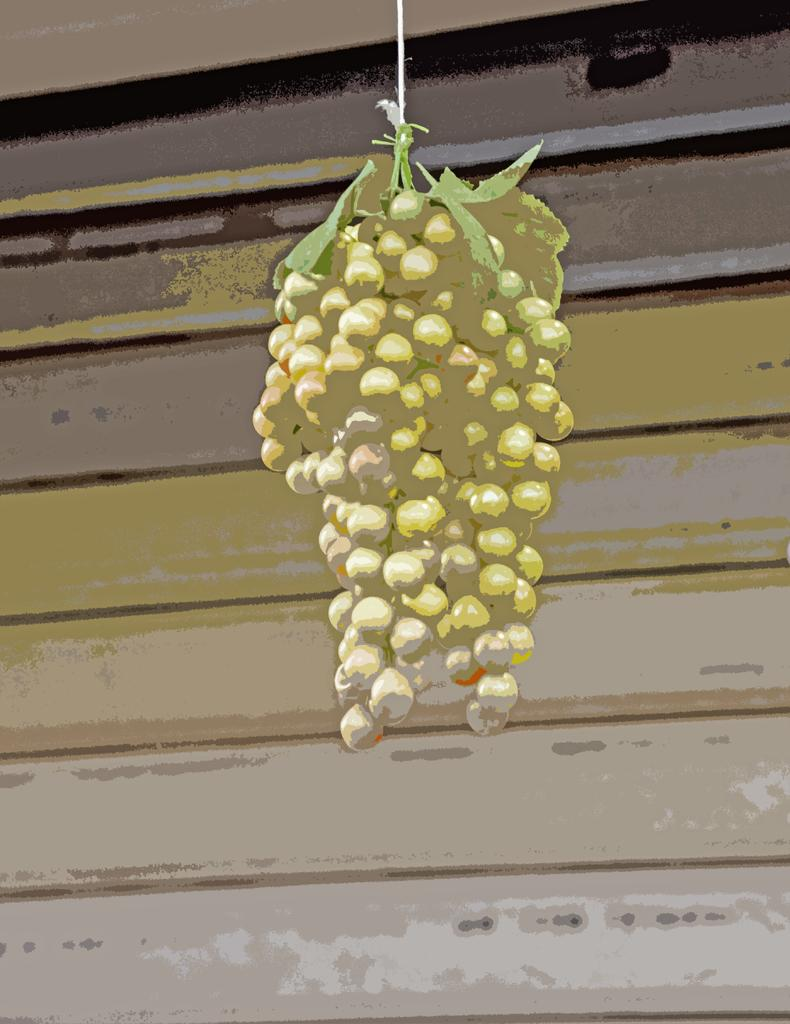What type of artwork is depicted in the image? The image is a painting. What is the main subject of the painting? There are grapes in the center of the painting. What can be seen in the background of the painting? There is a wall in the background of the painting. What type of coil is present in the painting? There is no coil present in the painting; it features grapes and a wall in the background. What color is the sky in the painting? The painting is not depicting a sky, so it is not possible to determine its color. 